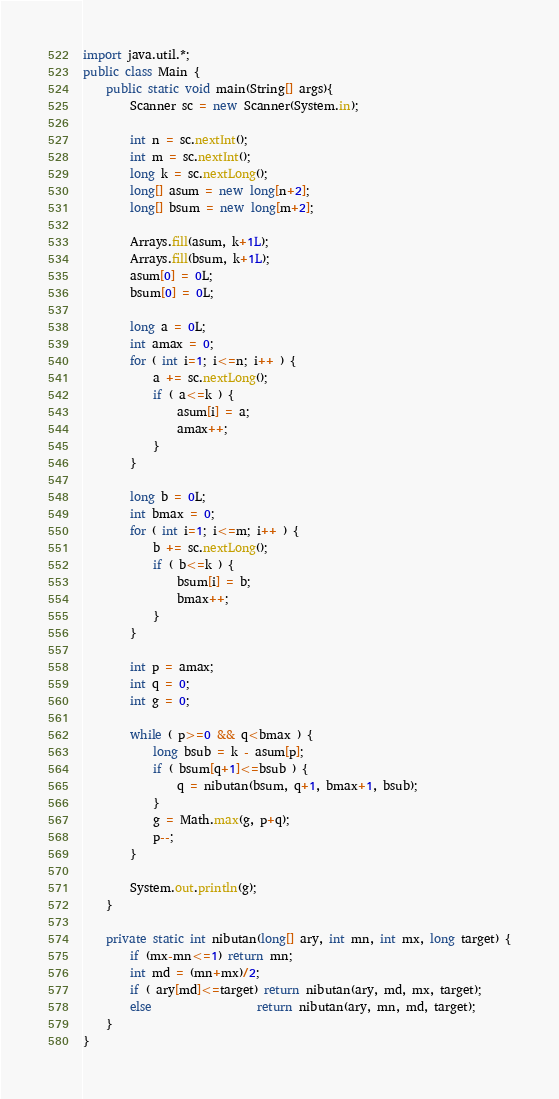<code> <loc_0><loc_0><loc_500><loc_500><_Java_>import java.util.*;
public class Main {
	public static void main(String[] args){
		Scanner sc = new Scanner(System.in);

		int n = sc.nextInt();
		int m = sc.nextInt();
		long k = sc.nextLong();
		long[] asum = new long[n+2];
		long[] bsum = new long[m+2];

		Arrays.fill(asum, k+1L);
		Arrays.fill(bsum, k+1L);
		asum[0] = 0L;
		bsum[0] = 0L;

		long a = 0L;
		int amax = 0;
		for ( int i=1; i<=n; i++ ) {
			a += sc.nextLong();
			if ( a<=k ) {
				asum[i] = a;
				amax++;
			}
		}

		long b = 0L;
		int bmax = 0;
		for ( int i=1; i<=m; i++ ) {
			b += sc.nextLong();
			if ( b<=k ) {
				bsum[i] = b;
				bmax++;
			}
		}

		int p = amax;
		int q = 0;
		int g = 0;

		while ( p>=0 && q<bmax ) {
			long bsub = k - asum[p];
			if ( bsum[q+1]<=bsub ) {
				q = nibutan(bsum, q+1, bmax+1, bsub);
			}
			g = Math.max(g, p+q);
			p--;
		}

		System.out.println(g);
	}

	private static int nibutan(long[] ary, int mn, int mx, long target) {
		if (mx-mn<=1) return mn;
		int md = (mn+mx)/2;
		if ( ary[md]<=target) return nibutan(ary, md, mx, target);
		else                  return nibutan(ary, mn, md, target);
	}
}</code> 